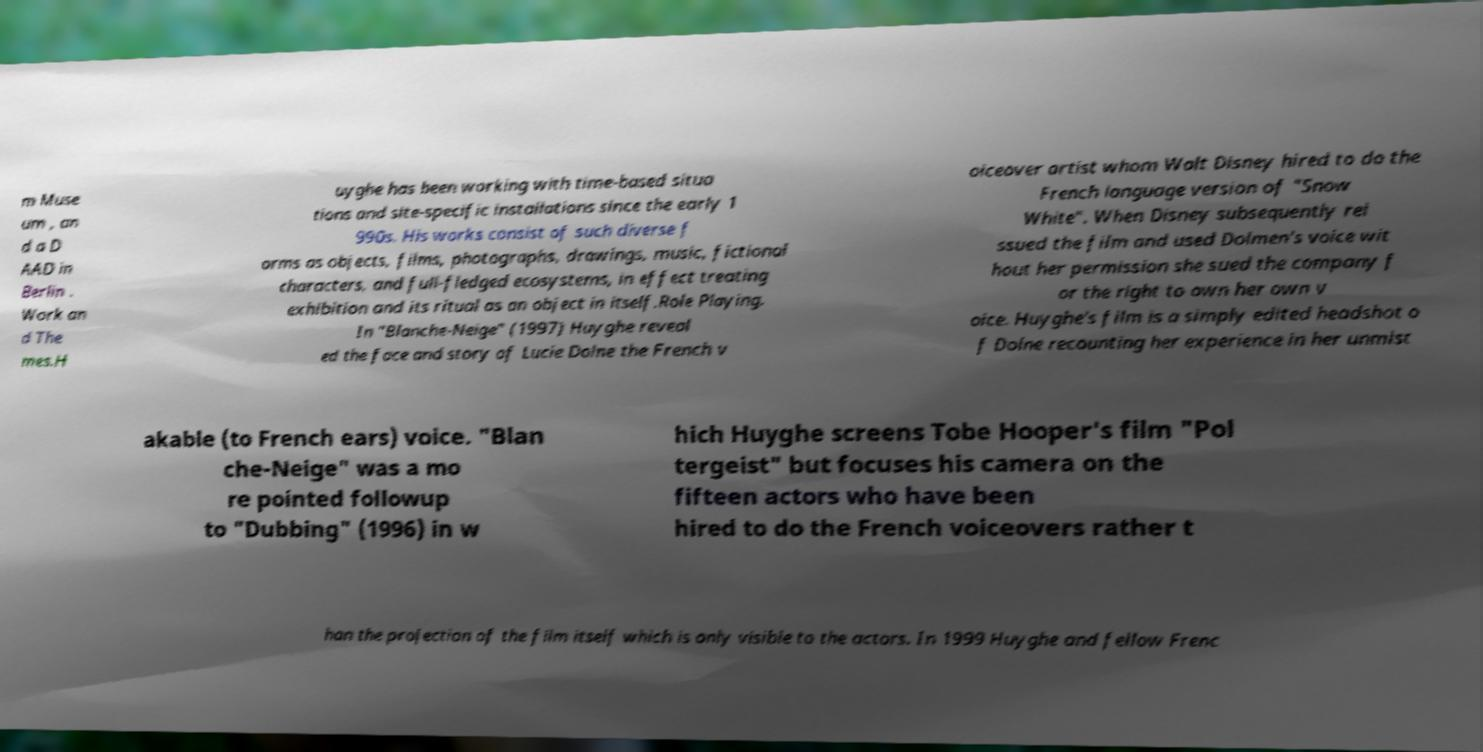There's text embedded in this image that I need extracted. Can you transcribe it verbatim? m Muse um , an d a D AAD in Berlin . Work an d The mes.H uyghe has been working with time-based situa tions and site-specific installations since the early 1 990s. His works consist of such diverse f orms as objects, films, photographs, drawings, music, fictional characters, and full-fledged ecosystems, in effect treating exhibition and its ritual as an object in itself.Role Playing. In "Blanche-Neige" (1997) Huyghe reveal ed the face and story of Lucie Dolne the French v oiceover artist whom Walt Disney hired to do the French language version of "Snow White". When Disney subsequently rei ssued the film and used Dolmen's voice wit hout her permission she sued the company f or the right to own her own v oice. Huyghe's film is a simply edited headshot o f Dolne recounting her experience in her unmist akable (to French ears) voice. "Blan che-Neige" was a mo re pointed followup to "Dubbing" (1996) in w hich Huyghe screens Tobe Hooper's film "Pol tergeist" but focuses his camera on the fifteen actors who have been hired to do the French voiceovers rather t han the projection of the film itself which is only visible to the actors. In 1999 Huyghe and fellow Frenc 